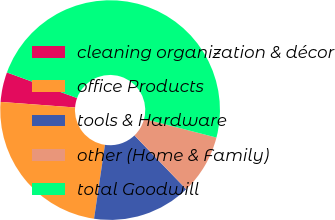<chart> <loc_0><loc_0><loc_500><loc_500><pie_chart><fcel>cleaning organization & décor<fcel>office Products<fcel>tools & Hardware<fcel>other (Home & Family)<fcel>total Goodwill<nl><fcel>4.38%<fcel>23.85%<fcel>14.53%<fcel>8.78%<fcel>48.46%<nl></chart> 